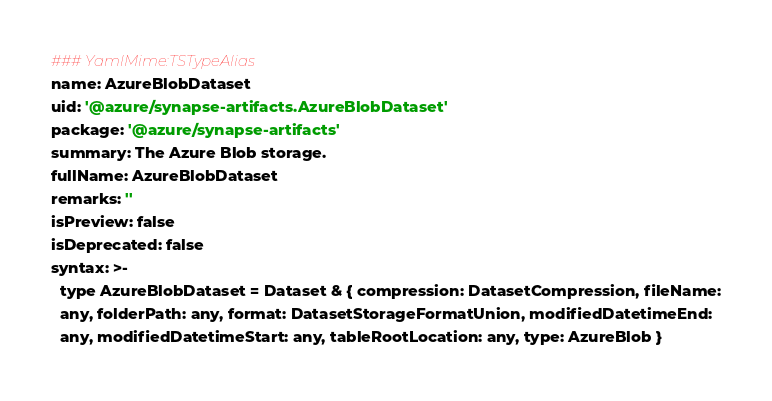Convert code to text. <code><loc_0><loc_0><loc_500><loc_500><_YAML_>### YamlMime:TSTypeAlias
name: AzureBlobDataset
uid: '@azure/synapse-artifacts.AzureBlobDataset'
package: '@azure/synapse-artifacts'
summary: The Azure Blob storage.
fullName: AzureBlobDataset
remarks: ''
isPreview: false
isDeprecated: false
syntax: >-
  type AzureBlobDataset = Dataset & { compression: DatasetCompression, fileName:
  any, folderPath: any, format: DatasetStorageFormatUnion, modifiedDatetimeEnd:
  any, modifiedDatetimeStart: any, tableRootLocation: any, type: AzureBlob }
</code> 